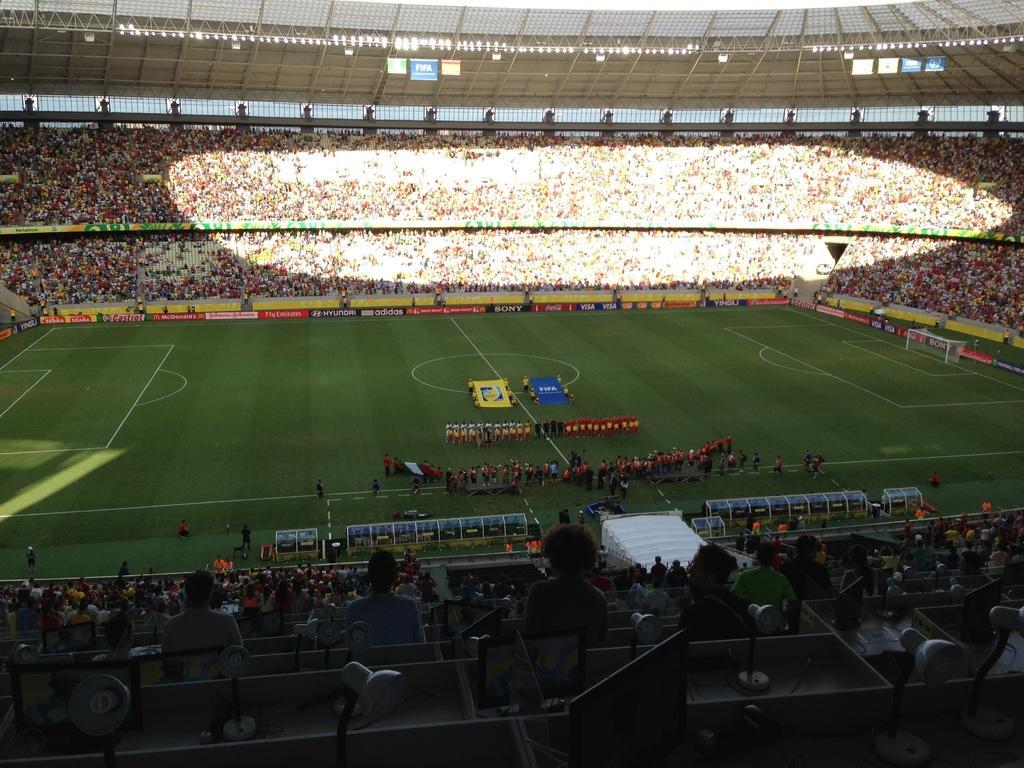Could you give a brief overview of what you see in this image? In this picture we can see a group of people sitting on chairs, some people are standing on the ground, flags, posters, lights, football net and some objects. 